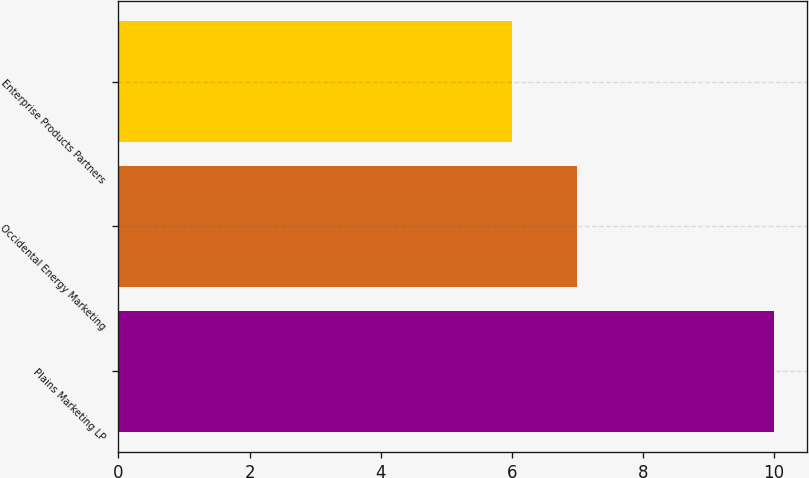<chart> <loc_0><loc_0><loc_500><loc_500><bar_chart><fcel>Plains Marketing LP<fcel>Occidental Energy Marketing<fcel>Enterprise Products Partners<nl><fcel>10<fcel>7<fcel>6<nl></chart> 